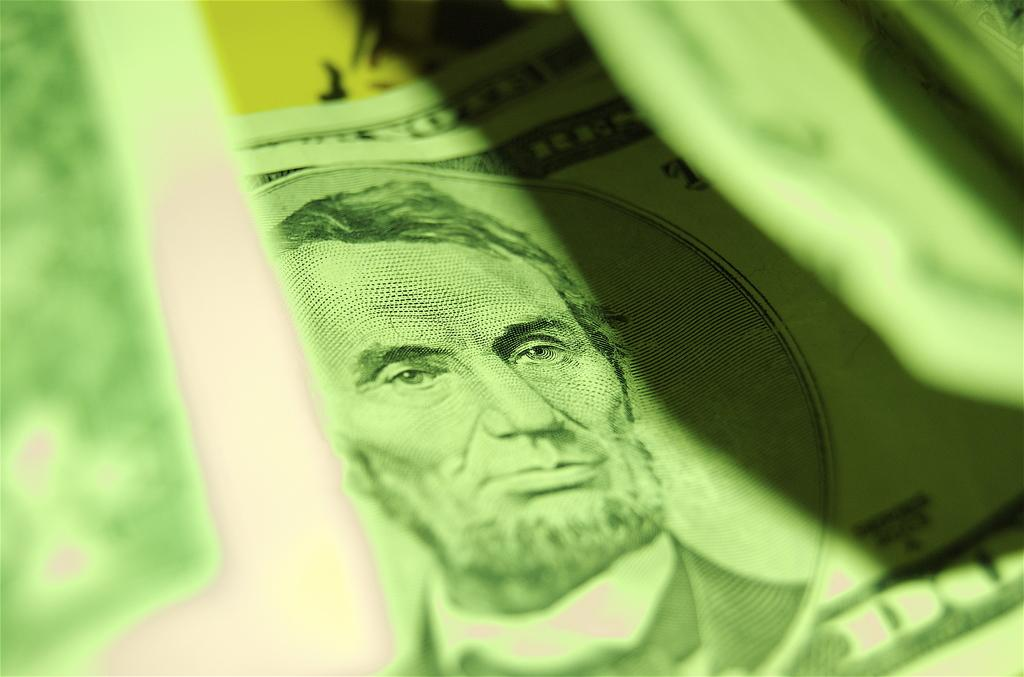What is present on the paper in the image? The paper contains a painting of a person. What color is the painting in the image? The painting is in green color. What other color can be seen in the background of the image? There is yellow color visible in the background of the image. What type of pain is the person in the painting experiencing? There is no indication of pain or any emotions in the painting, as it is a simple green representation of a person. 